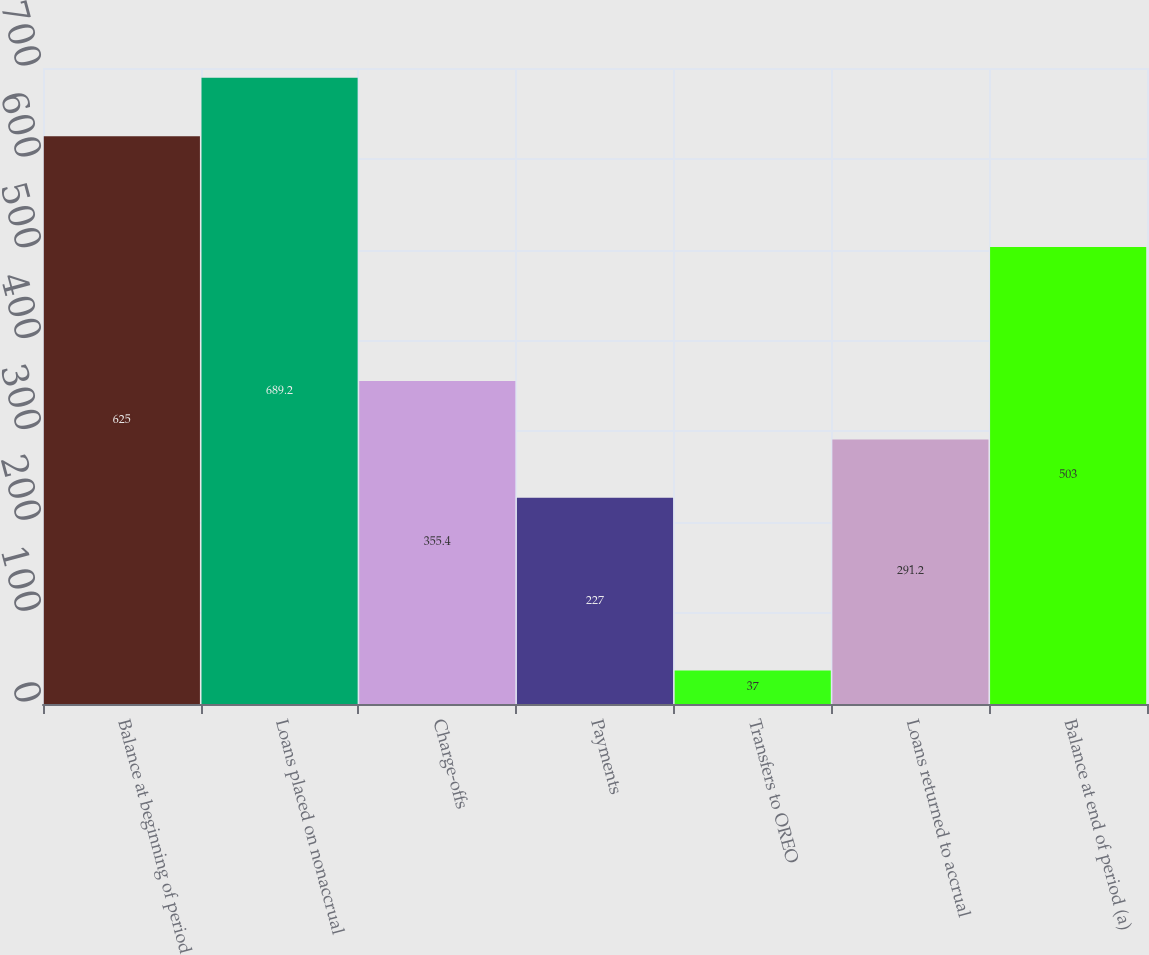Convert chart. <chart><loc_0><loc_0><loc_500><loc_500><bar_chart><fcel>Balance at beginning of period<fcel>Loans placed on nonaccrual<fcel>Charge-offs<fcel>Payments<fcel>Transfers to OREO<fcel>Loans returned to accrual<fcel>Balance at end of period (a)<nl><fcel>625<fcel>689.2<fcel>355.4<fcel>227<fcel>37<fcel>291.2<fcel>503<nl></chart> 